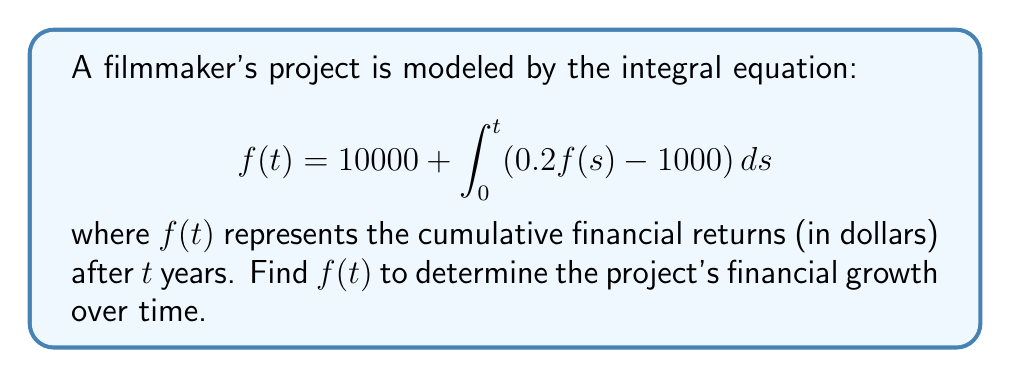Can you answer this question? Let's solve this step-by-step:

1) First, we recognize this as a Volterra integral equation of the second kind.

2) To solve it, we'll differentiate both sides with respect to $t$:

   $$f'(t) = \frac{d}{dt}\left[10000 + \int_0^t (0.2f(s) - 1000) ds\right]$$

3) Using the Fundamental Theorem of Calculus:

   $$f'(t) = 0.2f(t) - 1000$$

4) This is now a first-order linear differential equation. We can rearrange it:

   $$f'(t) - 0.2f(t) = -1000$$

5) The general solution to this type of equation is:

   $$f(t) = Ce^{0.2t} + 5000$$

   where $C$ is a constant and 5000 is the particular solution.

6) To find $C$, we use the initial condition $f(0) = 10000$ (from the original equation):

   $$10000 = C + 5000$$
   $$C = 5000$$

7) Therefore, the final solution is:

   $$f(t) = 5000e^{0.2t} + 5000$$

This represents the cumulative financial returns of the film project over time.
Answer: $f(t) = 5000e^{0.2t} + 5000$ 